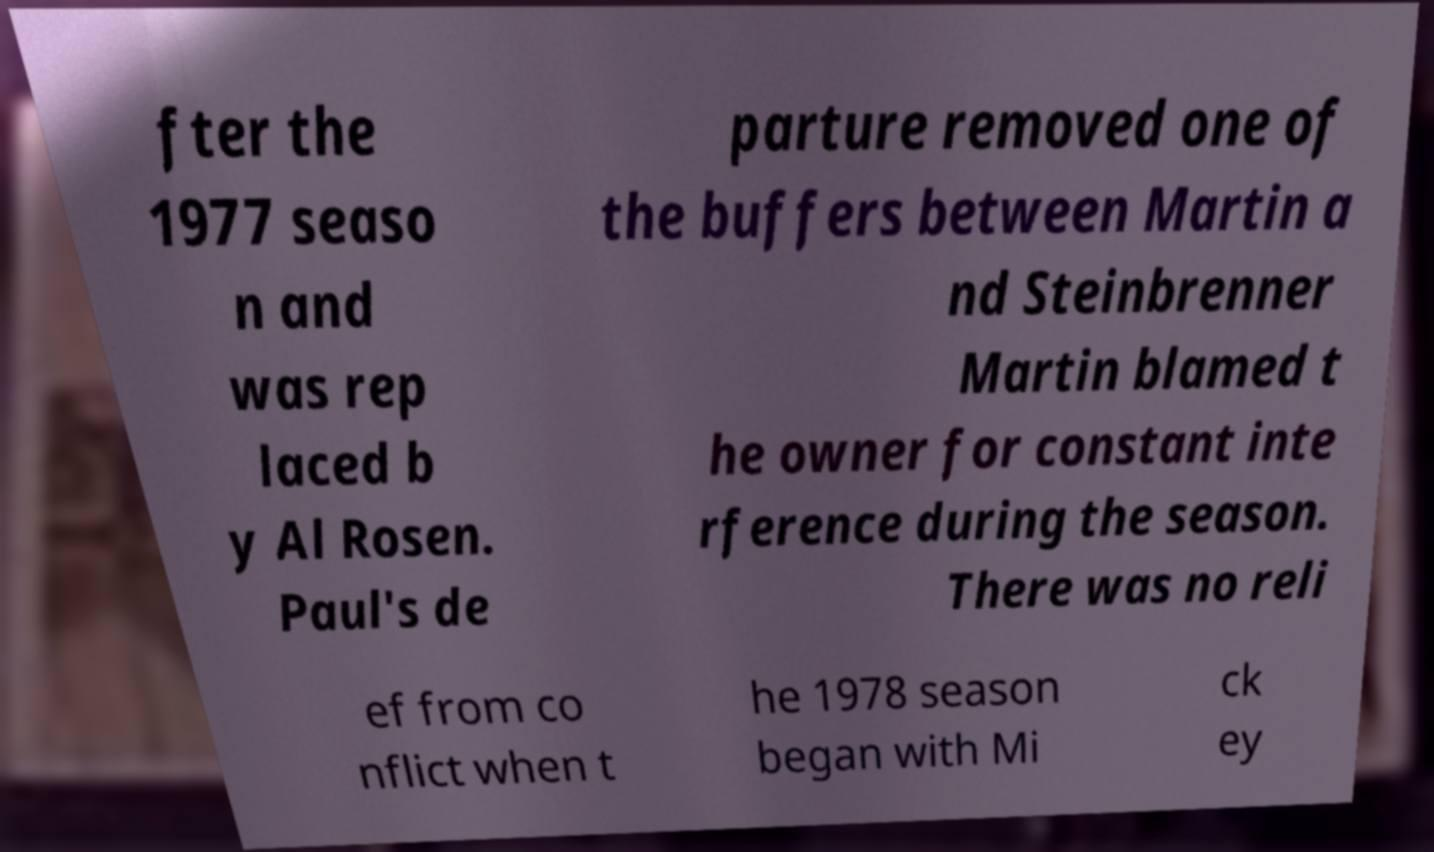Please identify and transcribe the text found in this image. fter the 1977 seaso n and was rep laced b y Al Rosen. Paul's de parture removed one of the buffers between Martin a nd Steinbrenner Martin blamed t he owner for constant inte rference during the season. There was no reli ef from co nflict when t he 1978 season began with Mi ck ey 